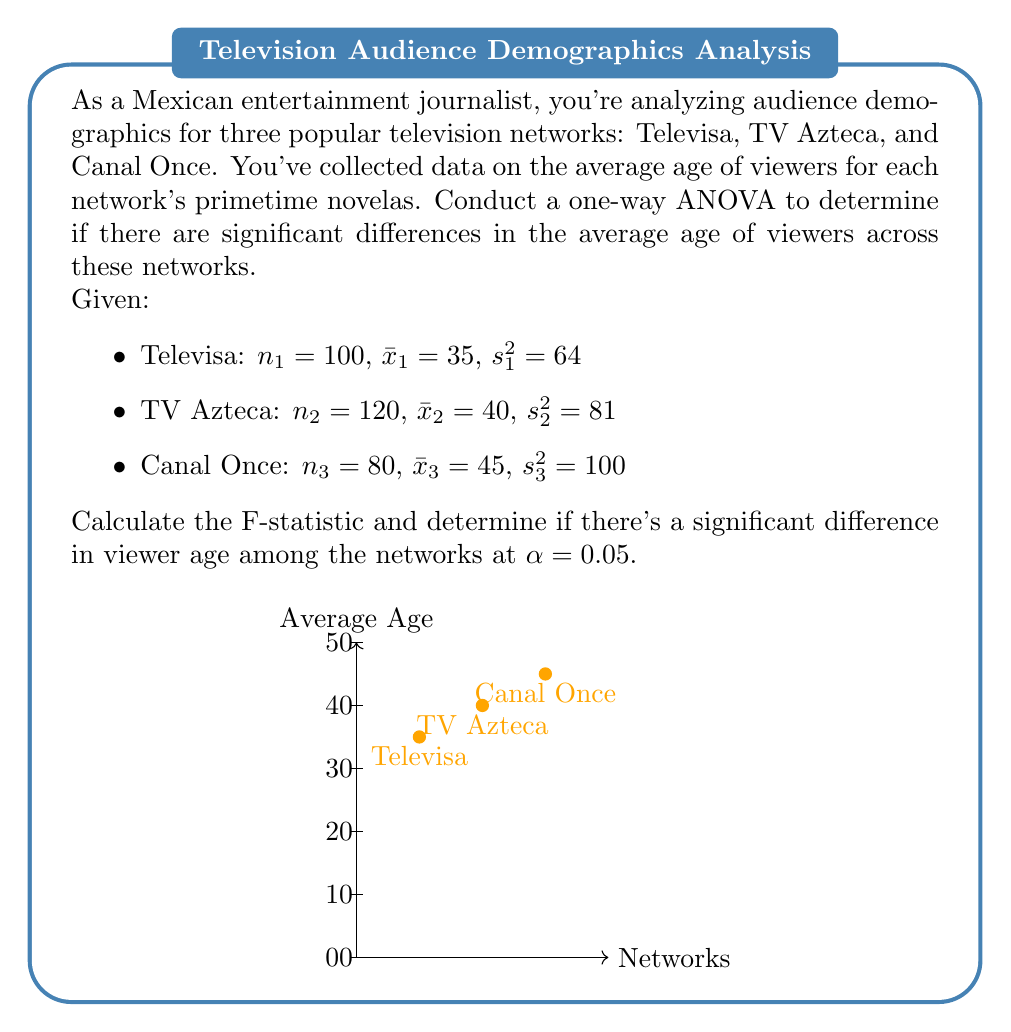Solve this math problem. To conduct a one-way ANOVA, we'll follow these steps:

1) Calculate the overall mean:
$$\bar{x} = \frac{n_1\bar{x}_1 + n_2\bar{x}_2 + n_3\bar{x}_3}{n_1 + n_2 + n_3} = \frac{100(35) + 120(40) + 80(45)}{300} = 39.67$$

2) Calculate SST (Total Sum of Squares):
$$SST = \sum_{i=1}^{3} (n_i - 1)s_i^2 + \sum_{i=1}^{3} n_i(\bar{x}_i - \bar{x})^2$$
$$SST = 99(64) + 119(81) + 79(100) + 100(35-39.67)^2 + 120(40-39.67)^2 + 80(45-39.67)^2$$
$$SST = 25,036$$

3) Calculate SSB (Between-group Sum of Squares):
$$SSB = \sum_{i=1}^{3} n_i(\bar{x}_i - \bar{x})^2 = 100(35-39.67)^2 + 120(40-39.67)^2 + 80(45-39.67)^2 = 4,166.67$$

4) Calculate SSW (Within-group Sum of Squares):
$$SSW = SST - SSB = 25,036 - 4,166.67 = 20,869.33$$

5) Calculate degrees of freedom:
$$df_{between} = k - 1 = 3 - 1 = 2$$
$$df_{within} = N - k = 300 - 3 = 297$$

6) Calculate Mean Square Between (MSB) and Mean Square Within (MSW):
$$MSB = \frac{SSB}{df_{between}} = \frac{4,166.67}{2} = 2,083.33$$
$$MSW = \frac{SSW}{df_{within}} = \frac{20,869.33}{297} = 70.27$$

7) Calculate the F-statistic:
$$F = \frac{MSB}{MSW} = \frac{2,083.33}{70.27} = 29.65$$

8) Compare with the critical F-value:
At $\alpha = 0.05$, $F_{critical}(2, 297) \approx 3.03$

Since $F_{calculated} = 29.65 > F_{critical} = 3.03$, we reject the null hypothesis.
Answer: $F = 29.65$; significant difference in viewer age among networks (p < 0.05) 